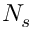<formula> <loc_0><loc_0><loc_500><loc_500>N _ { s }</formula> 